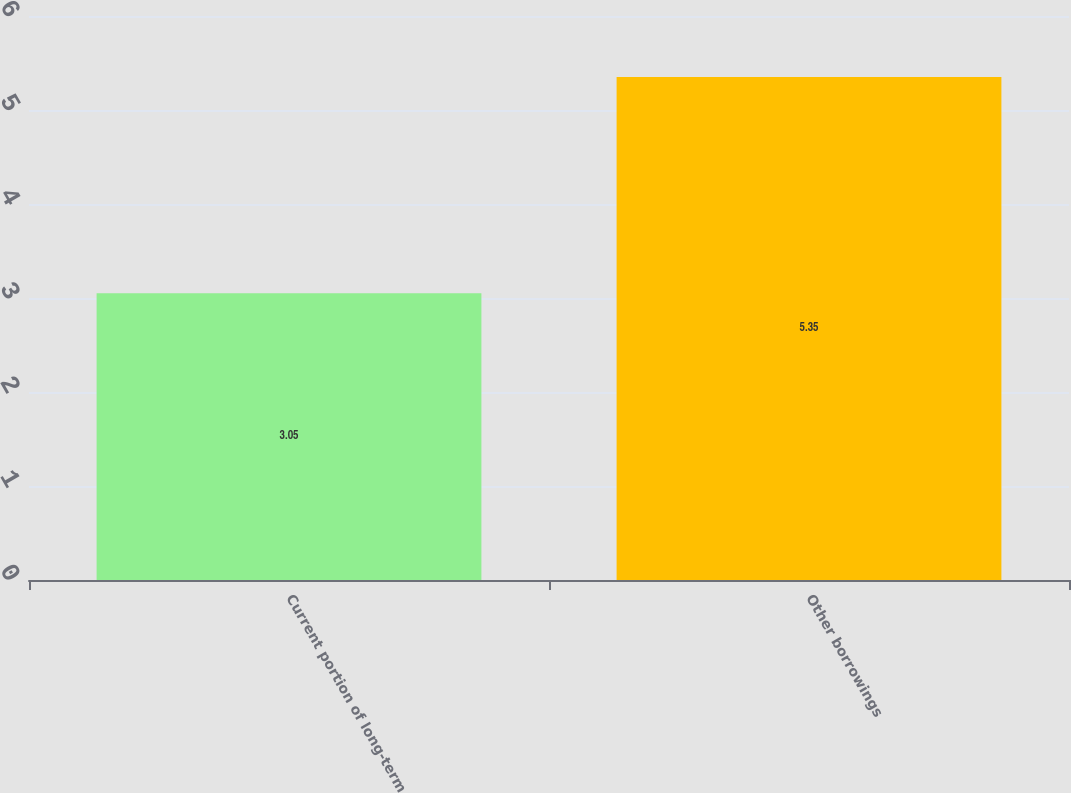Convert chart. <chart><loc_0><loc_0><loc_500><loc_500><bar_chart><fcel>Current portion of long-term<fcel>Other borrowings<nl><fcel>3.05<fcel>5.35<nl></chart> 